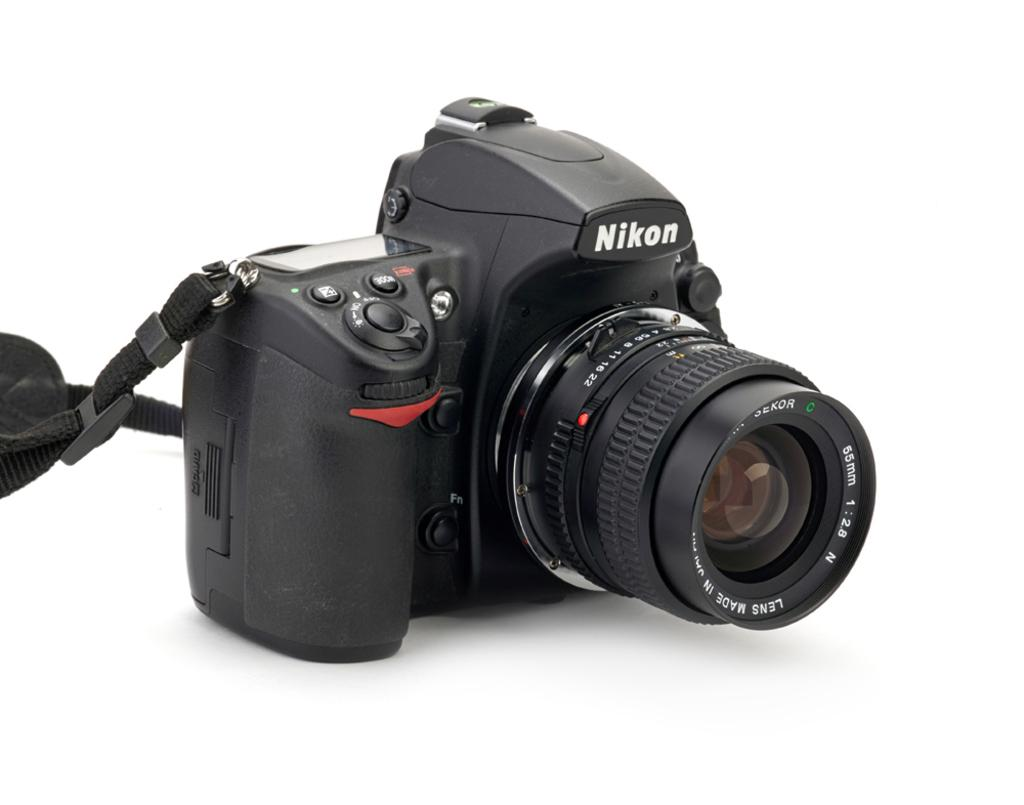What type of camera is visible in the image? There is a black color camera in the image. What is the color of the surface the camera is placed on? The camera is on a white color surface. How many horses are running in the cemetery in the image? There are no horses or cemetery present in the image; it features a black color camera on a white color surface. 